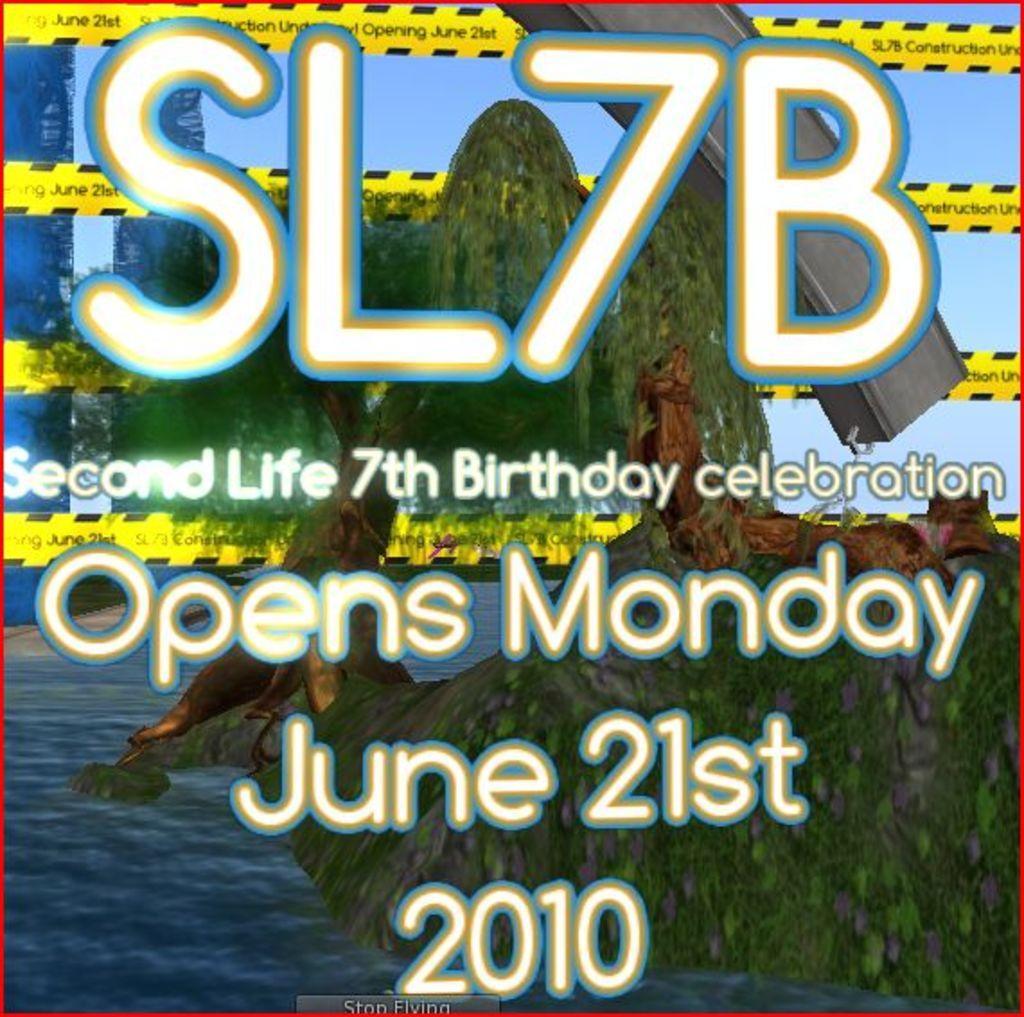Describe this image in one or two sentences. We can see poster, in this poster we can see trees, water and some text. 